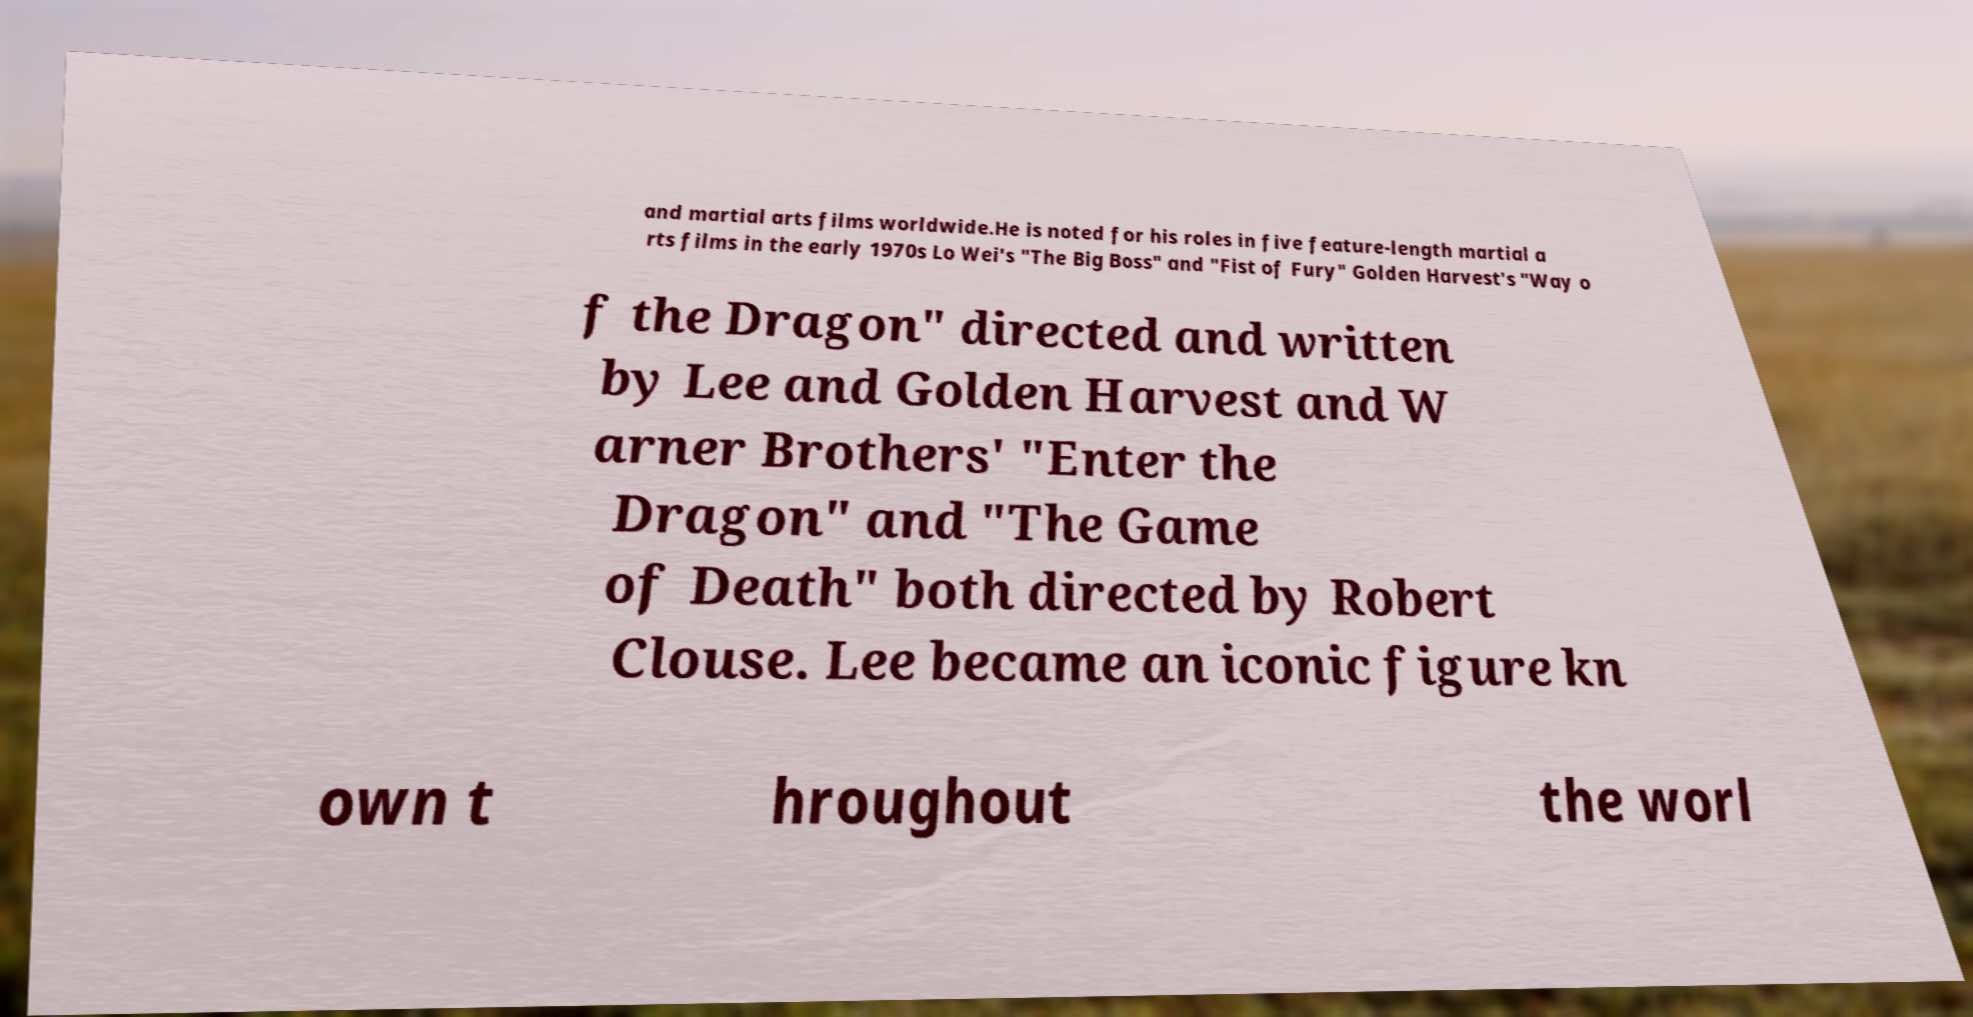Can you read and provide the text displayed in the image?This photo seems to have some interesting text. Can you extract and type it out for me? and martial arts films worldwide.He is noted for his roles in five feature-length martial a rts films in the early 1970s Lo Wei's "The Big Boss" and "Fist of Fury" Golden Harvest's "Way o f the Dragon" directed and written by Lee and Golden Harvest and W arner Brothers' "Enter the Dragon" and "The Game of Death" both directed by Robert Clouse. Lee became an iconic figure kn own t hroughout the worl 